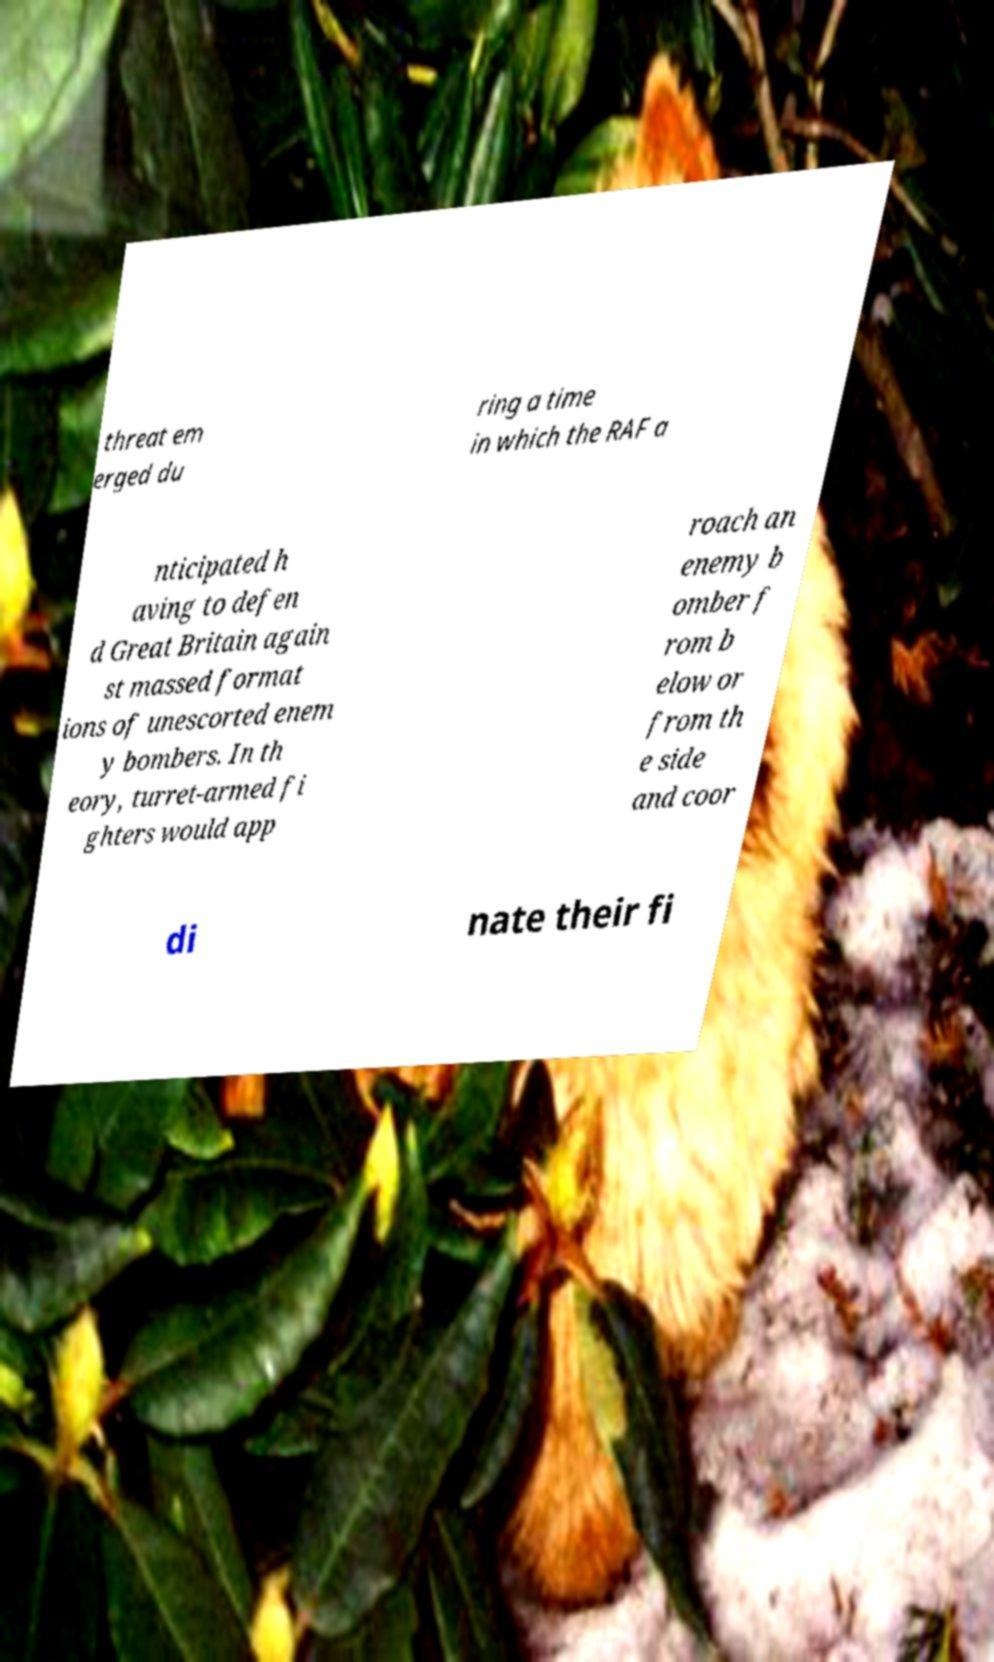Can you read and provide the text displayed in the image?This photo seems to have some interesting text. Can you extract and type it out for me? threat em erged du ring a time in which the RAF a nticipated h aving to defen d Great Britain again st massed format ions of unescorted enem y bombers. In th eory, turret-armed fi ghters would app roach an enemy b omber f rom b elow or from th e side and coor di nate their fi 